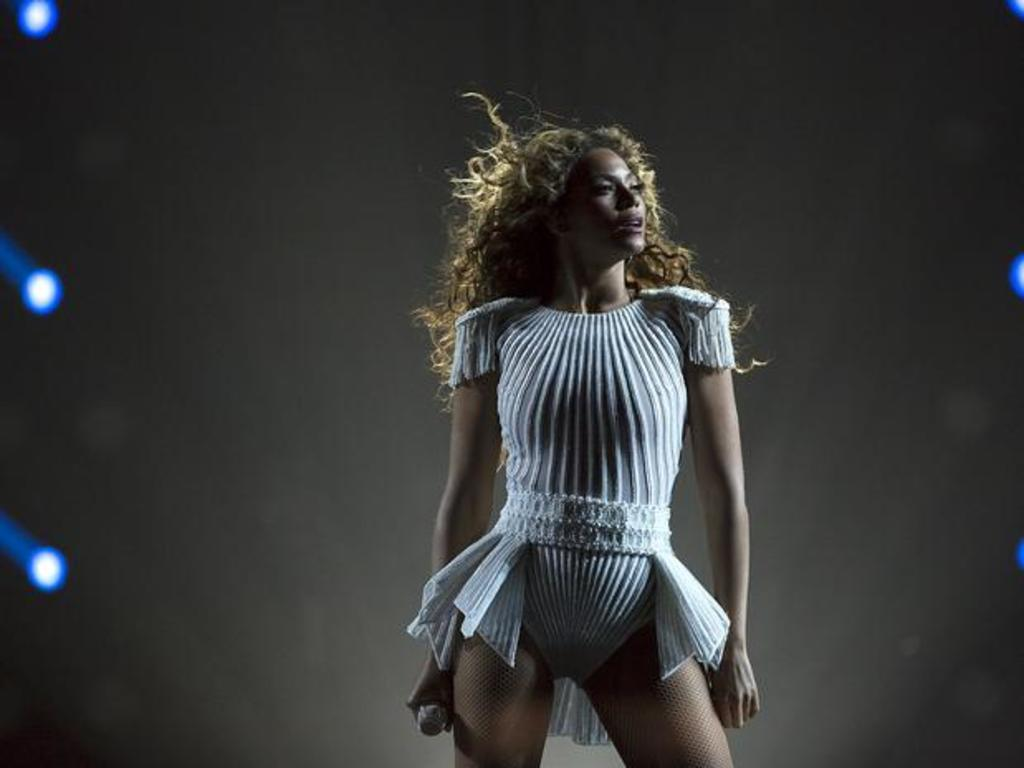Who is the main subject in the image? There is a woman in the image. What is the woman wearing? The woman is wearing a dress. What is the woman holding in the image? The woman is holding a microphone. What can be seen in the background of the image? There are lights visible in the background of the image. What type of necklace is the woman wearing in the image? There is no necklace visible in the image; the woman is wearing a dress. How does the ice form on the microphone in the image? There is no ice present on the microphone in the image; the woman is holding a regular microphone. 